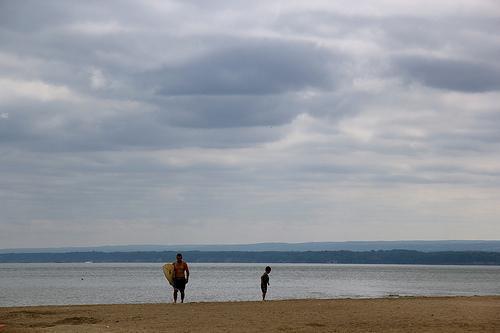How many people are in the picture?
Give a very brief answer. 2. 